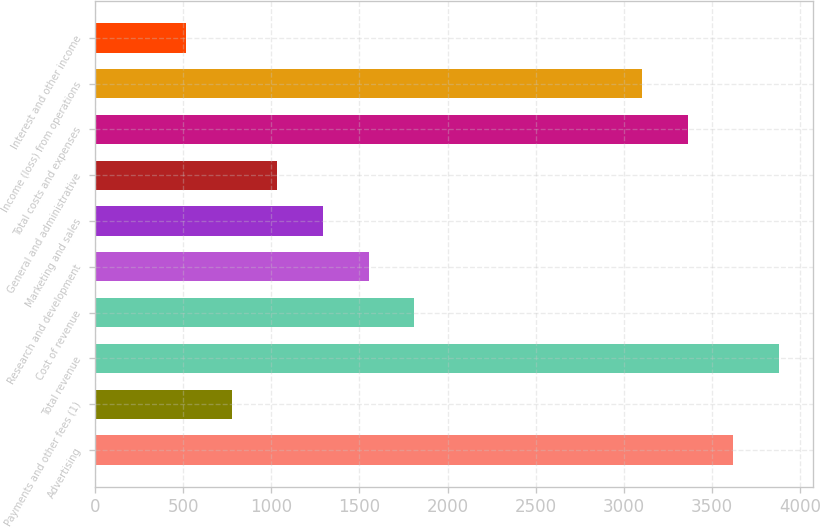Convert chart to OTSL. <chart><loc_0><loc_0><loc_500><loc_500><bar_chart><fcel>Advertising<fcel>Payments and other fees (1)<fcel>Total revenue<fcel>Cost of revenue<fcel>Research and development<fcel>Marketing and sales<fcel>General and administrative<fcel>Total costs and expenses<fcel>Income (loss) from operations<fcel>Interest and other income<nl><fcel>3618.92<fcel>775.64<fcel>3877.4<fcel>1809.56<fcel>1551.08<fcel>1292.6<fcel>1034.12<fcel>3360.44<fcel>3101.96<fcel>517.16<nl></chart> 